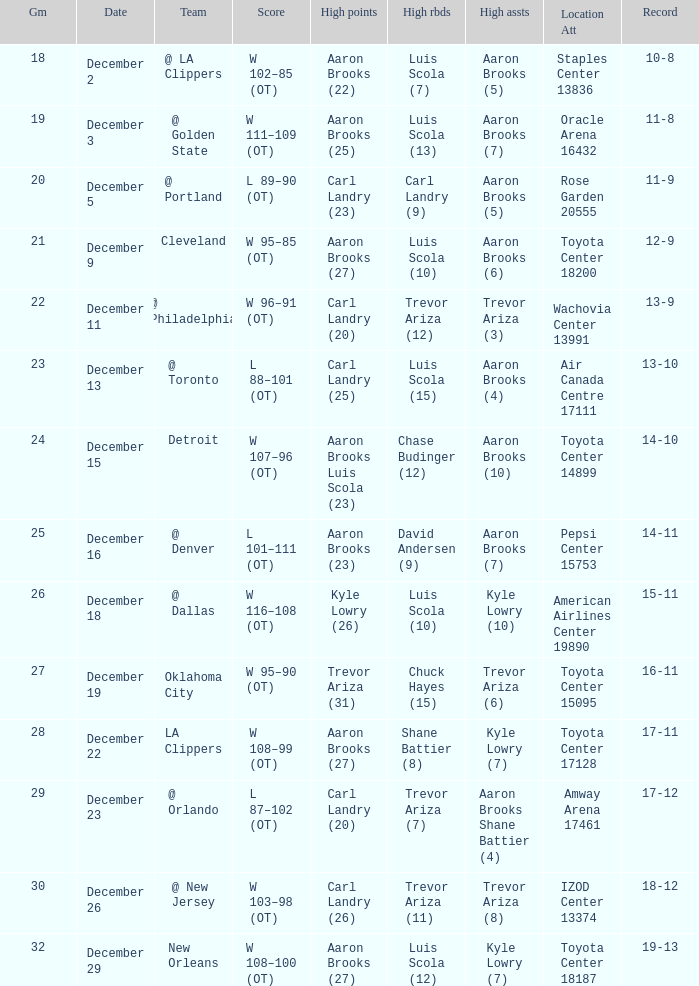Who did the high rebounds in the game where Carl Landry (23) did the most high points? Carl Landry (9). Would you be able to parse every entry in this table? {'header': ['Gm', 'Date', 'Team', 'Score', 'High points', 'High rbds', 'High assts', 'Location Att', 'Record'], 'rows': [['18', 'December 2', '@ LA Clippers', 'W 102–85 (OT)', 'Aaron Brooks (22)', 'Luis Scola (7)', 'Aaron Brooks (5)', 'Staples Center 13836', '10-8'], ['19', 'December 3', '@ Golden State', 'W 111–109 (OT)', 'Aaron Brooks (25)', 'Luis Scola (13)', 'Aaron Brooks (7)', 'Oracle Arena 16432', '11-8'], ['20', 'December 5', '@ Portland', 'L 89–90 (OT)', 'Carl Landry (23)', 'Carl Landry (9)', 'Aaron Brooks (5)', 'Rose Garden 20555', '11-9'], ['21', 'December 9', 'Cleveland', 'W 95–85 (OT)', 'Aaron Brooks (27)', 'Luis Scola (10)', 'Aaron Brooks (6)', 'Toyota Center 18200', '12-9'], ['22', 'December 11', '@ Philadelphia', 'W 96–91 (OT)', 'Carl Landry (20)', 'Trevor Ariza (12)', 'Trevor Ariza (3)', 'Wachovia Center 13991', '13-9'], ['23', 'December 13', '@ Toronto', 'L 88–101 (OT)', 'Carl Landry (25)', 'Luis Scola (15)', 'Aaron Brooks (4)', 'Air Canada Centre 17111', '13-10'], ['24', 'December 15', 'Detroit', 'W 107–96 (OT)', 'Aaron Brooks Luis Scola (23)', 'Chase Budinger (12)', 'Aaron Brooks (10)', 'Toyota Center 14899', '14-10'], ['25', 'December 16', '@ Denver', 'L 101–111 (OT)', 'Aaron Brooks (23)', 'David Andersen (9)', 'Aaron Brooks (7)', 'Pepsi Center 15753', '14-11'], ['26', 'December 18', '@ Dallas', 'W 116–108 (OT)', 'Kyle Lowry (26)', 'Luis Scola (10)', 'Kyle Lowry (10)', 'American Airlines Center 19890', '15-11'], ['27', 'December 19', 'Oklahoma City', 'W 95–90 (OT)', 'Trevor Ariza (31)', 'Chuck Hayes (15)', 'Trevor Ariza (6)', 'Toyota Center 15095', '16-11'], ['28', 'December 22', 'LA Clippers', 'W 108–99 (OT)', 'Aaron Brooks (27)', 'Shane Battier (8)', 'Kyle Lowry (7)', 'Toyota Center 17128', '17-11'], ['29', 'December 23', '@ Orlando', 'L 87–102 (OT)', 'Carl Landry (20)', 'Trevor Ariza (7)', 'Aaron Brooks Shane Battier (4)', 'Amway Arena 17461', '17-12'], ['30', 'December 26', '@ New Jersey', 'W 103–98 (OT)', 'Carl Landry (26)', 'Trevor Ariza (11)', 'Trevor Ariza (8)', 'IZOD Center 13374', '18-12'], ['32', 'December 29', 'New Orleans', 'W 108–100 (OT)', 'Aaron Brooks (27)', 'Luis Scola (12)', 'Kyle Lowry (7)', 'Toyota Center 18187', '19-13']]} 